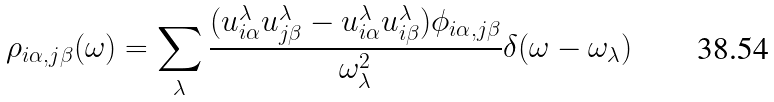Convert formula to latex. <formula><loc_0><loc_0><loc_500><loc_500>\rho _ { i \alpha , j \beta } ( \omega ) = \sum _ { \lambda } \frac { ( u _ { i \alpha } ^ { \lambda } u _ { j \beta } ^ { \lambda } - u _ { i \alpha } ^ { \lambda } u _ { i \beta } ^ { \lambda } ) \phi _ { i \alpha , j \beta } } { \omega _ { \lambda } ^ { 2 } } \delta ( \omega - \omega _ { \lambda } )</formula> 